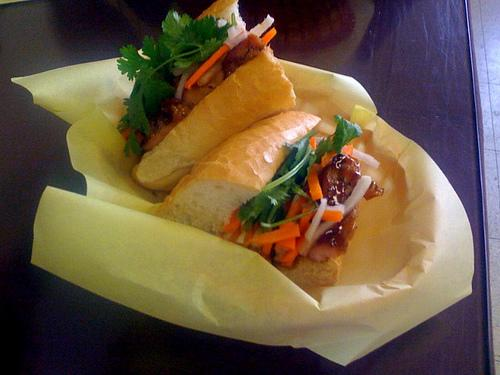How many individual sandwich pieces are in the image?

Choices:
A) four
B) seven
C) nine
D) two two 